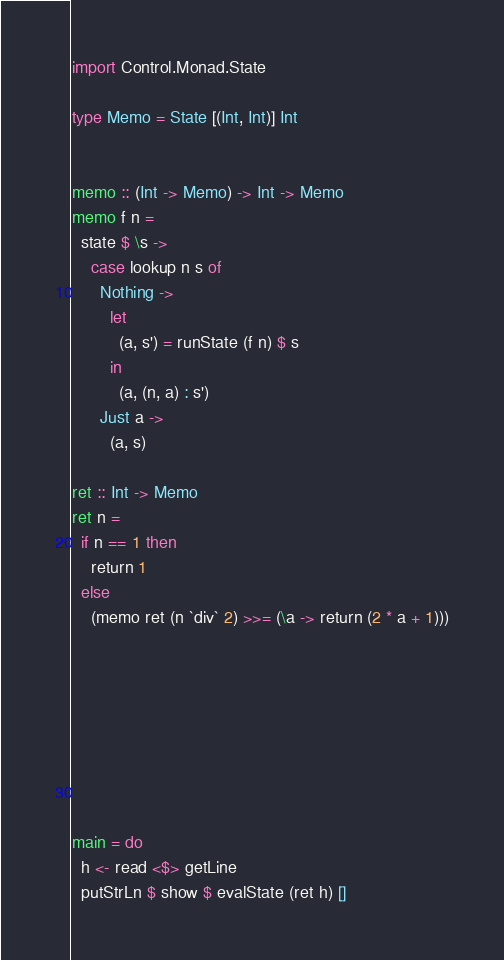Convert code to text. <code><loc_0><loc_0><loc_500><loc_500><_Haskell_>import Control.Monad.State

type Memo = State [(Int, Int)] Int


memo :: (Int -> Memo) -> Int -> Memo 
memo f n =
  state $ \s ->
    case lookup n s of
      Nothing -> 
        let 
          (a, s') = runState (f n) $ s
        in 
          (a, (n, a) : s')
      Just a ->
        (a, s)

ret :: Int -> Memo
ret n = 
  if n == 1 then
    return 1
  else
    (memo ret (n `div` 2) >>= (\a -> return (2 * a + 1)))








main = do
  h <- read <$> getLine
  putStrLn $ show $ evalState (ret h) []
</code> 